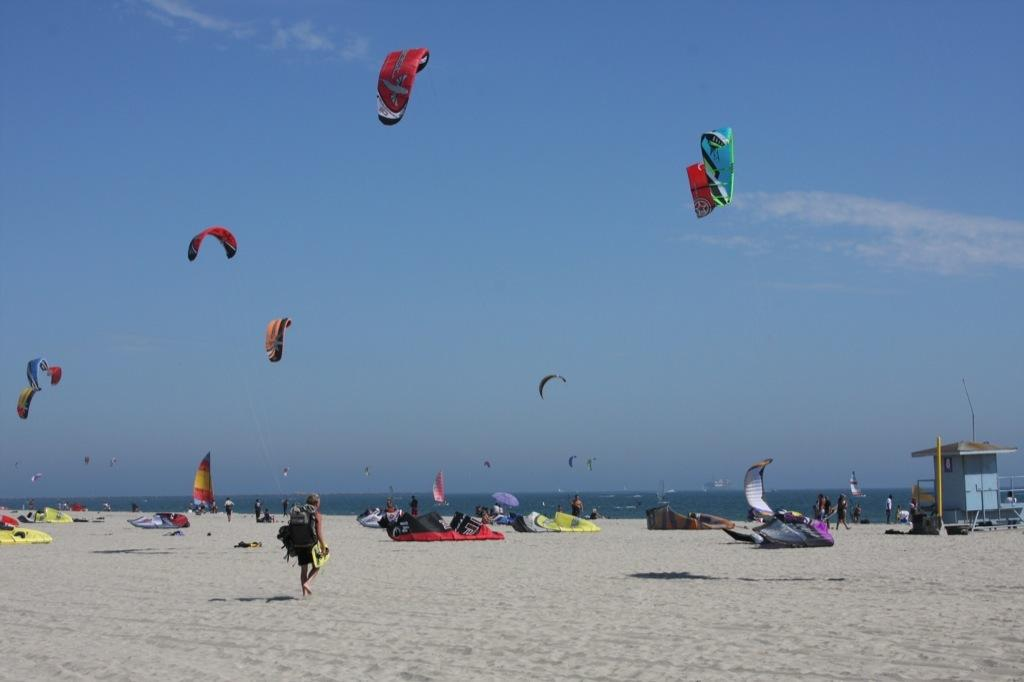What is located at the top of the image? There are air balloons at the top of the image. What is present at the bottom of the image? There is sand at the bottom of the image. What can be seen in the background of the image? There is water visible in the background of the image. How far away is the basketball court from the sand in the image? There is no basketball court present in the image, so it is not possible to determine the distance between it and the sand. 